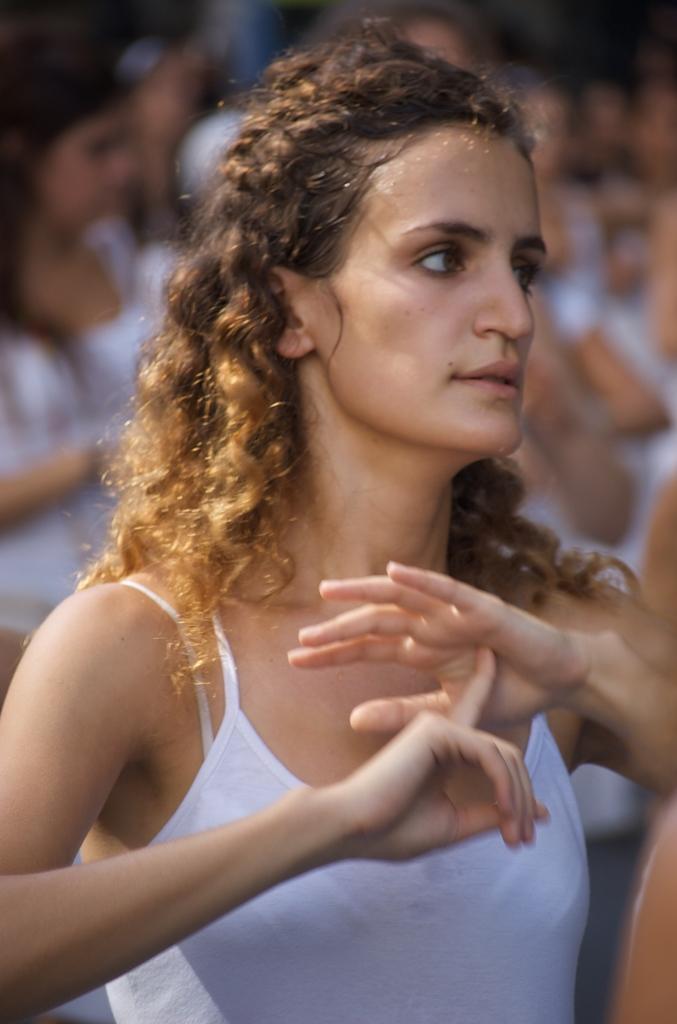Could you give a brief overview of what you see in this image? A woman is standing wearing a white vest. The background is blurred. 